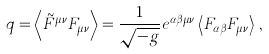<formula> <loc_0><loc_0><loc_500><loc_500>q = \left < \tilde { F } ^ { \mu \nu } F _ { \mu \nu } \right > = \frac { 1 } { \sqrt { - g } } e ^ { \alpha \beta \mu \nu } \left < F _ { \alpha \beta } F _ { \mu \nu } \right > \, ,</formula> 